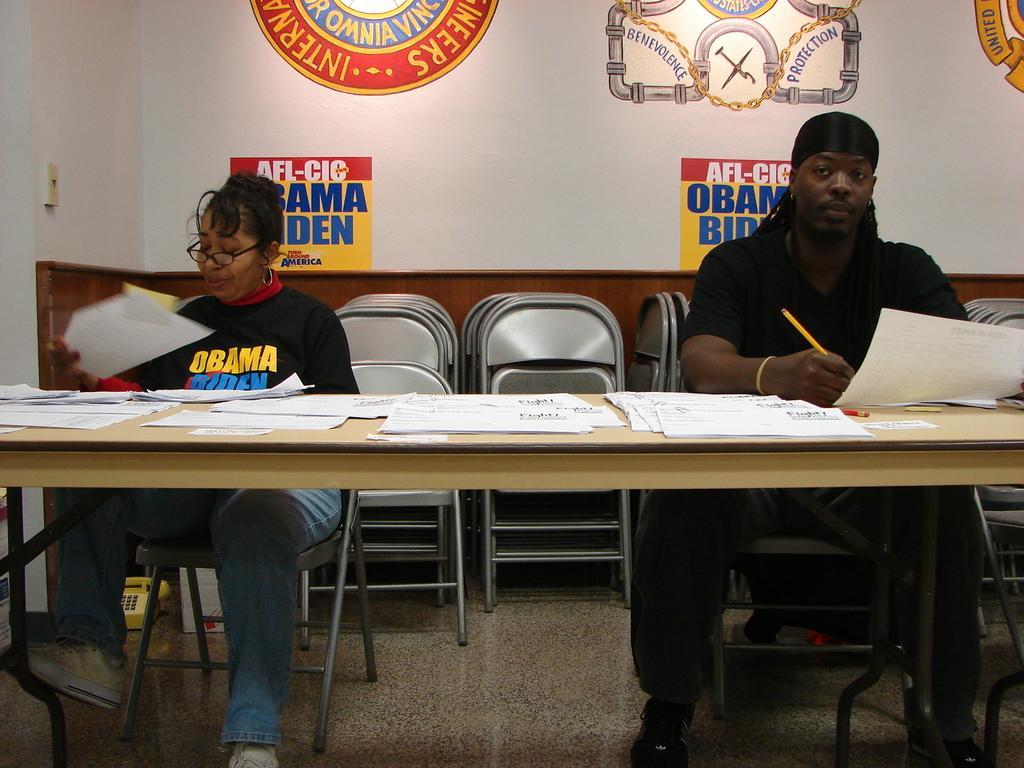Describe this image in one or two sentences. In this picture two people are sitting on the table and papers are on top of it , in the background we also observed many posts attached to the wall. 